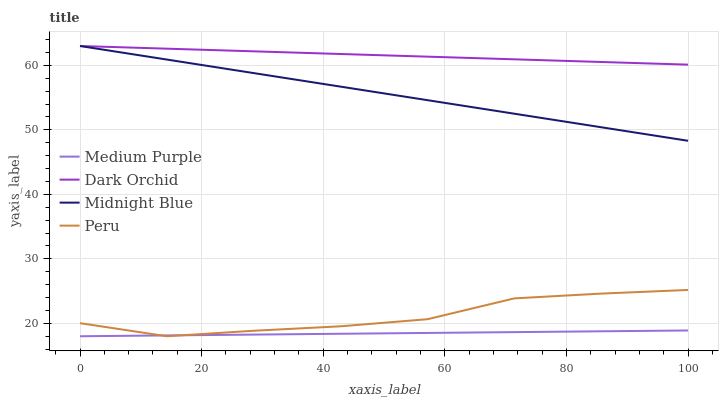Does Peru have the minimum area under the curve?
Answer yes or no. No. Does Peru have the maximum area under the curve?
Answer yes or no. No. Is Midnight Blue the smoothest?
Answer yes or no. No. Is Midnight Blue the roughest?
Answer yes or no. No. Does Midnight Blue have the lowest value?
Answer yes or no. No. Does Peru have the highest value?
Answer yes or no. No. Is Peru less than Dark Orchid?
Answer yes or no. Yes. Is Midnight Blue greater than Peru?
Answer yes or no. Yes. Does Peru intersect Dark Orchid?
Answer yes or no. No. 